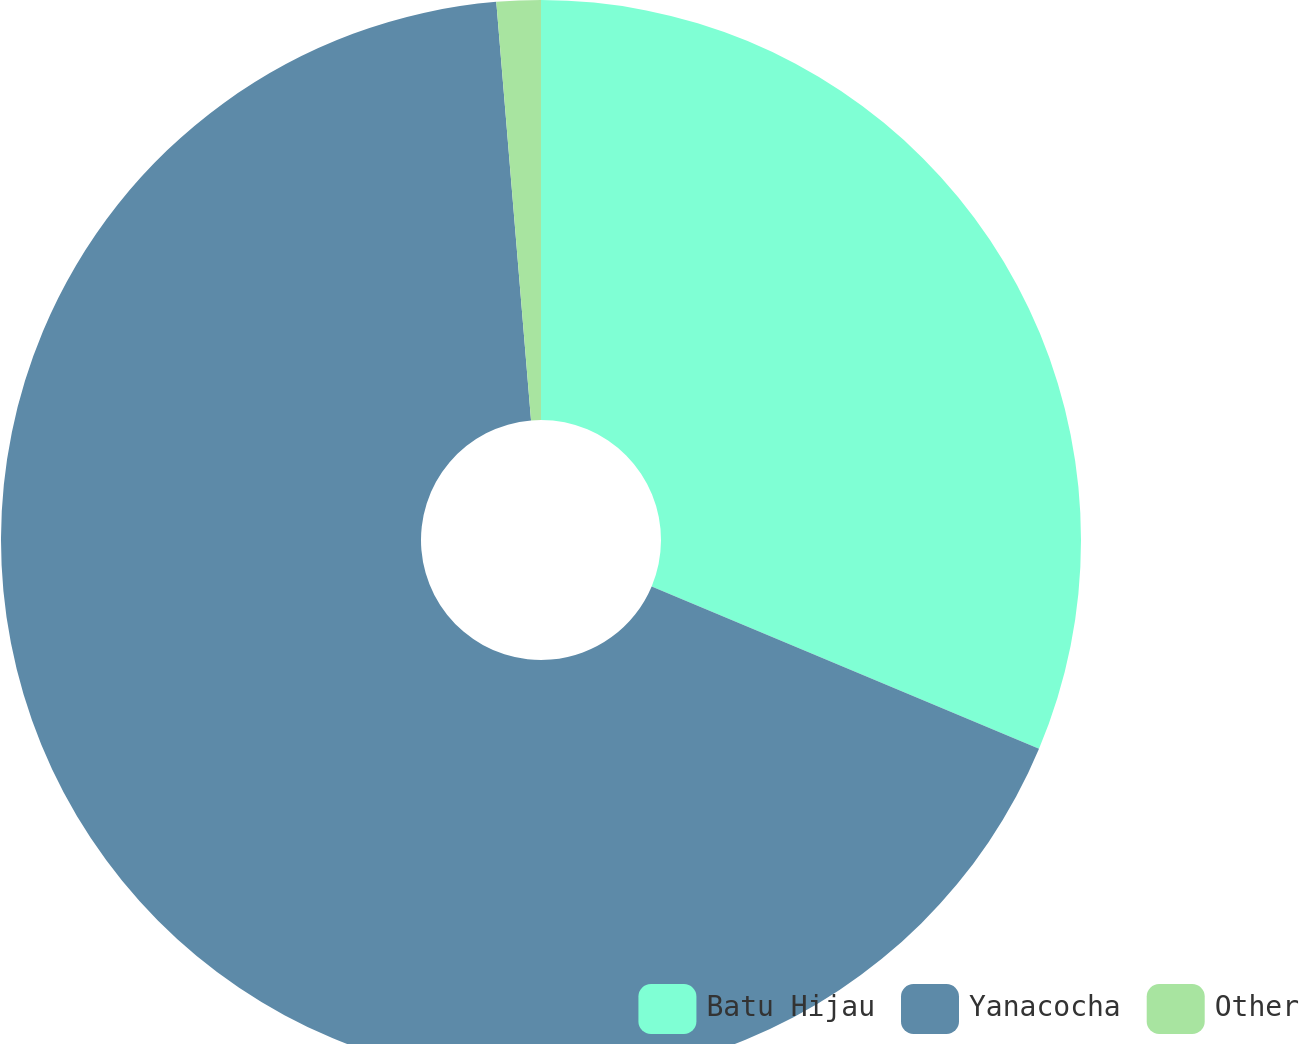Convert chart to OTSL. <chart><loc_0><loc_0><loc_500><loc_500><pie_chart><fcel>Batu Hijau<fcel>Yanacocha<fcel>Other<nl><fcel>31.32%<fcel>67.37%<fcel>1.32%<nl></chart> 